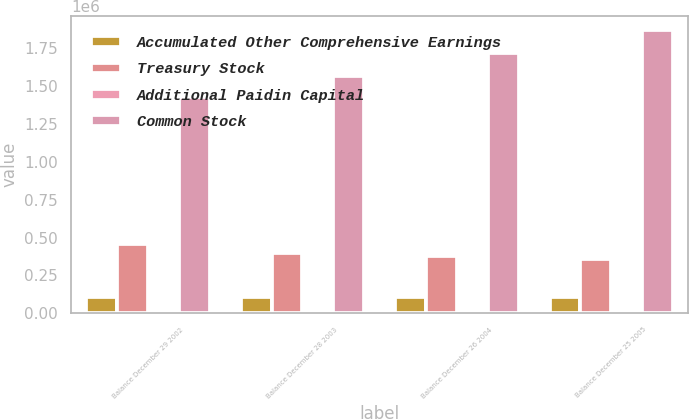Convert chart to OTSL. <chart><loc_0><loc_0><loc_500><loc_500><stacked_bar_chart><ecel><fcel>Balance December 29 2002<fcel>Balance December 28 2003<fcel>Balance December 26 2004<fcel>Balance December 25 2005<nl><fcel>Accumulated Other Comprehensive Earnings<fcel>104847<fcel>104847<fcel>104847<fcel>104847<nl><fcel>Treasury Stock<fcel>458130<fcel>397878<fcel>380745<fcel>358199<nl><fcel>Additional Paidin Capital<fcel>613<fcel>679<fcel>98<fcel>24<nl><fcel>Common Stock<fcel>1.43095e+06<fcel>1.56769e+06<fcel>1.72121e+06<fcel>1.86901e+06<nl></chart> 